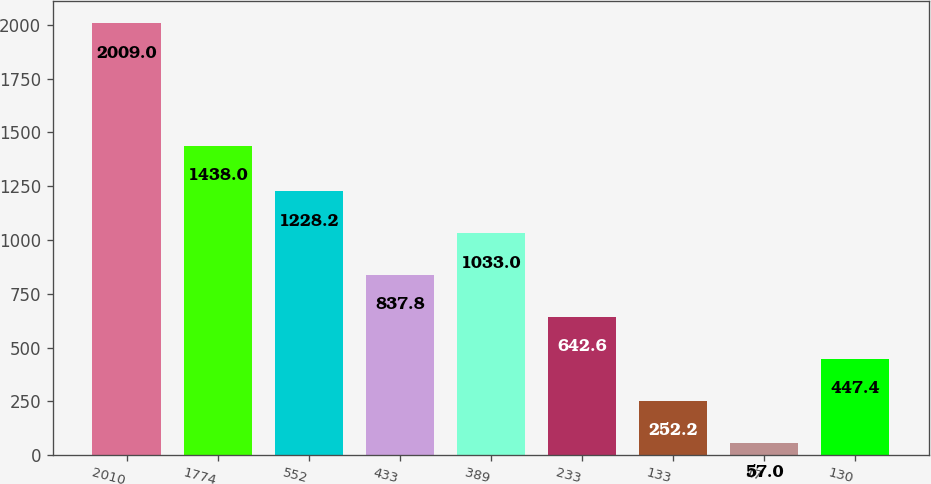Convert chart to OTSL. <chart><loc_0><loc_0><loc_500><loc_500><bar_chart><fcel>2010<fcel>1774<fcel>552<fcel>433<fcel>389<fcel>233<fcel>133<fcel>17<fcel>130<nl><fcel>2009<fcel>1438<fcel>1228.2<fcel>837.8<fcel>1033<fcel>642.6<fcel>252.2<fcel>57<fcel>447.4<nl></chart> 